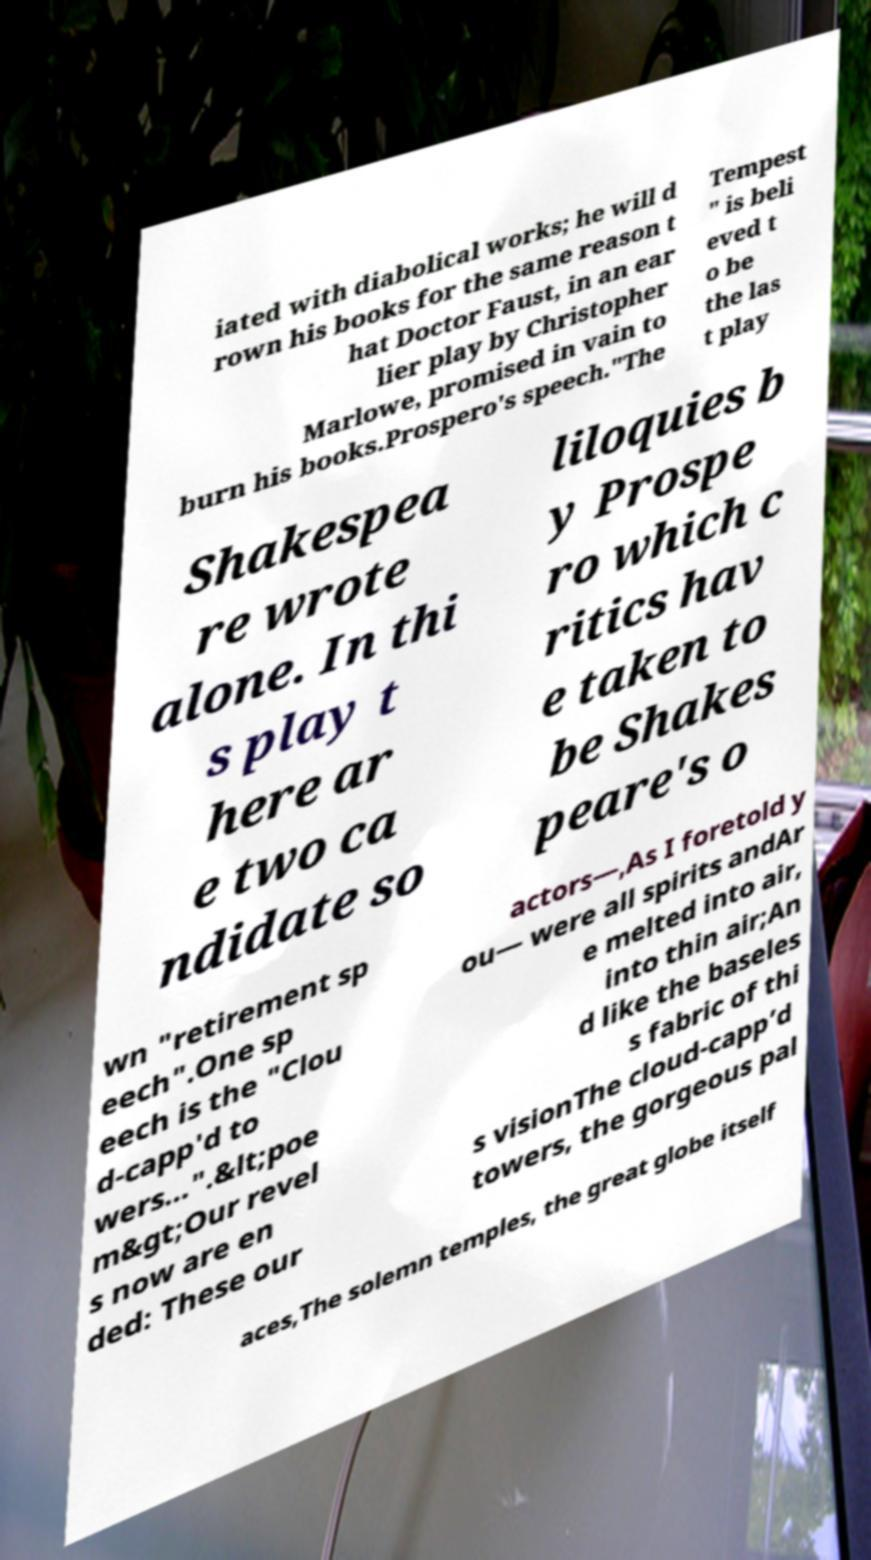There's text embedded in this image that I need extracted. Can you transcribe it verbatim? iated with diabolical works; he will d rown his books for the same reason t hat Doctor Faust, in an ear lier play by Christopher Marlowe, promised in vain to burn his books.Prospero's speech."The Tempest " is beli eved t o be the las t play Shakespea re wrote alone. In thi s play t here ar e two ca ndidate so liloquies b y Prospe ro which c ritics hav e taken to be Shakes peare's o wn "retirement sp eech".One sp eech is the "Clou d-capp'd to wers...".&lt;poe m&gt;Our revel s now are en ded: These our actors—,As I foretold y ou— were all spirits andAr e melted into air, into thin air;An d like the baseles s fabric of thi s visionThe cloud-capp’d towers, the gorgeous pal aces,The solemn temples, the great globe itself 